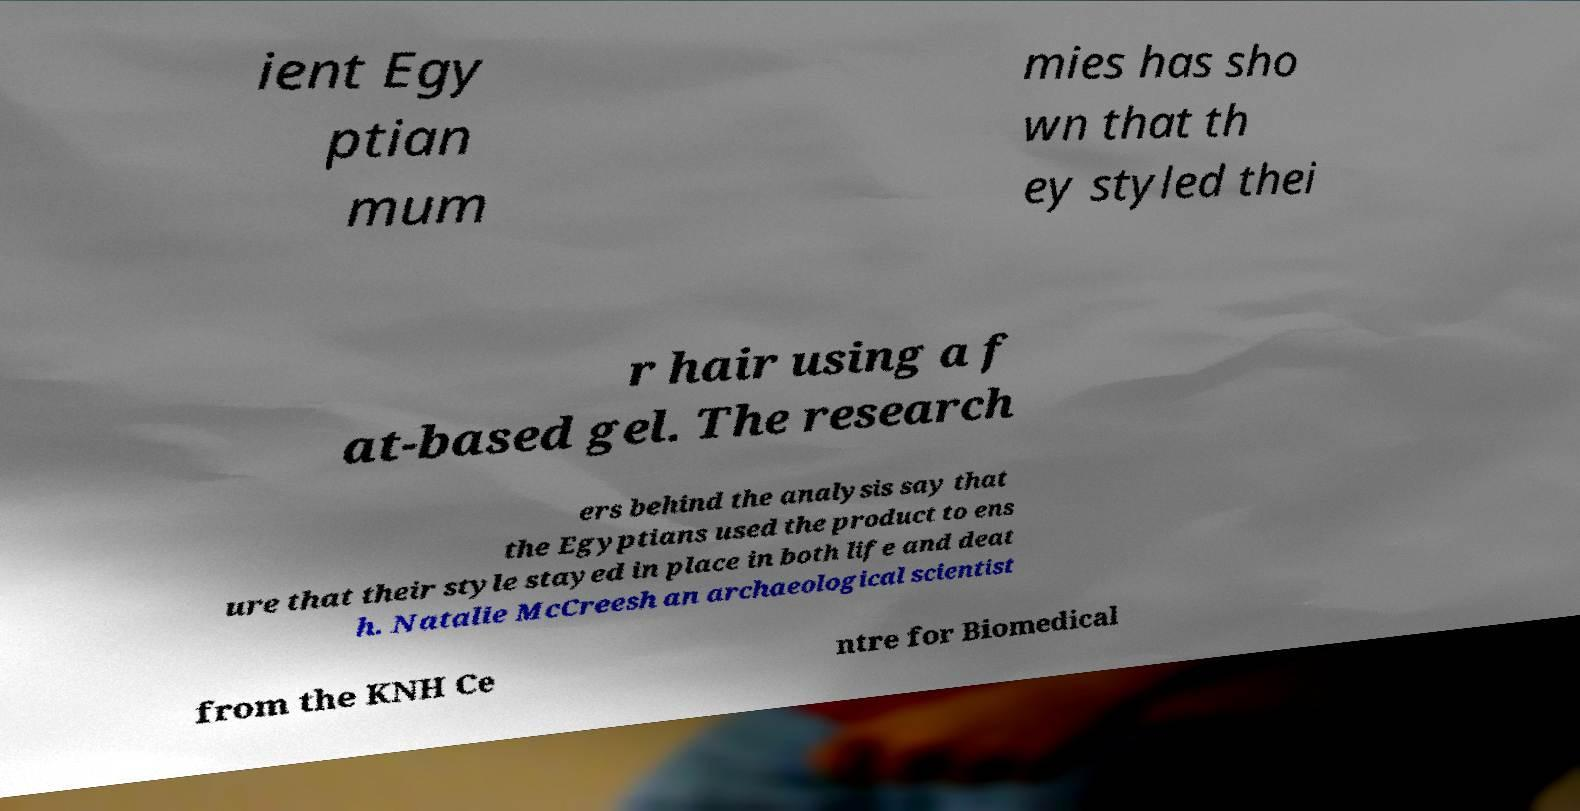What messages or text are displayed in this image? I need them in a readable, typed format. ient Egy ptian mum mies has sho wn that th ey styled thei r hair using a f at-based gel. The research ers behind the analysis say that the Egyptians used the product to ens ure that their style stayed in place in both life and deat h. Natalie McCreesh an archaeological scientist from the KNH Ce ntre for Biomedical 